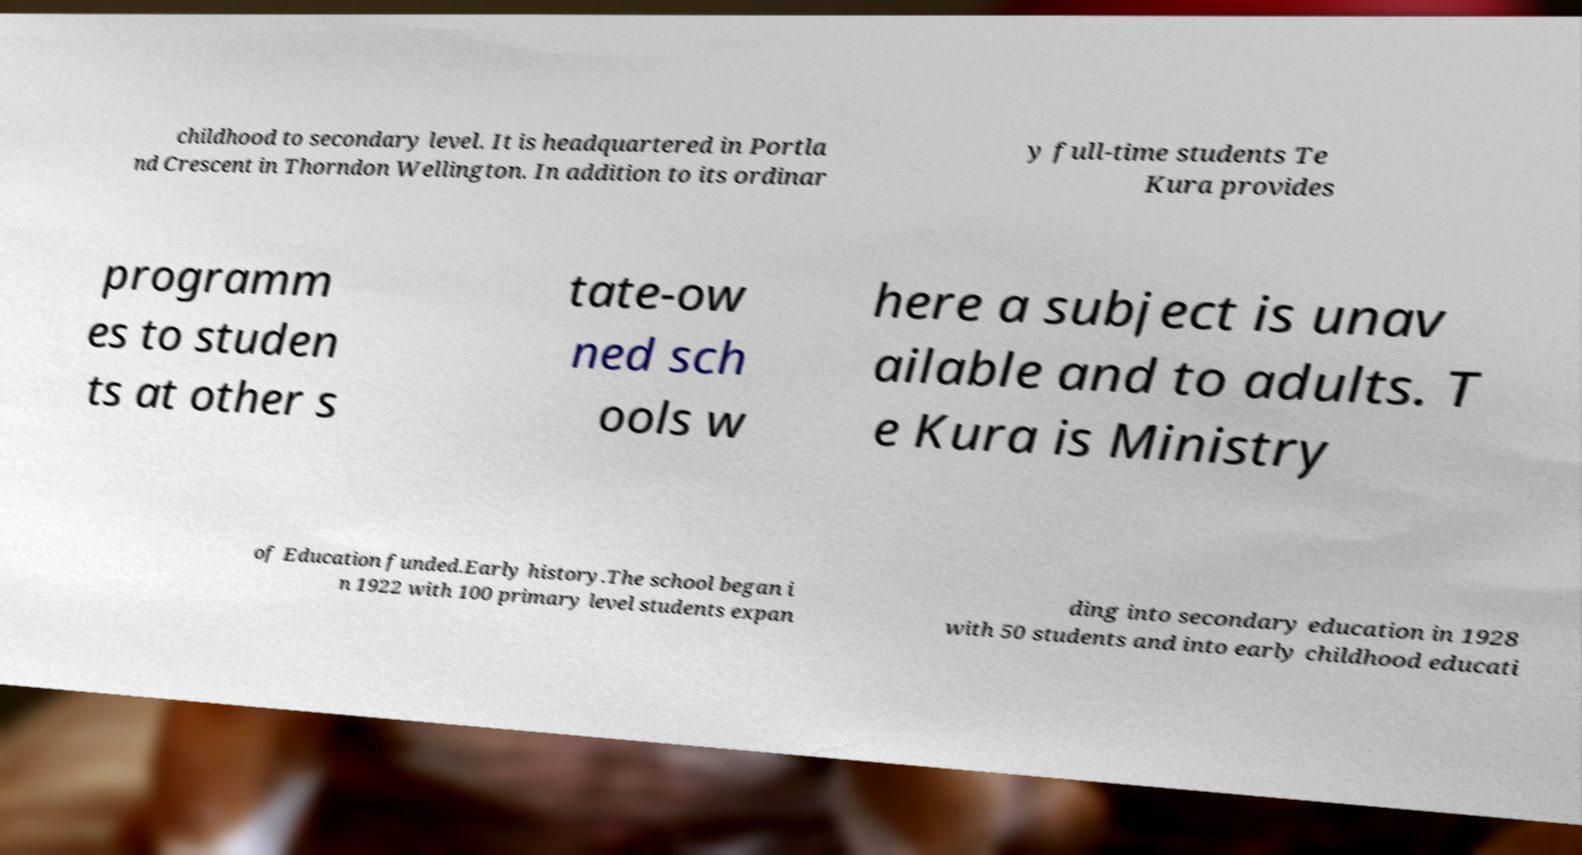Please identify and transcribe the text found in this image. childhood to secondary level. It is headquartered in Portla nd Crescent in Thorndon Wellington. In addition to its ordinar y full-time students Te Kura provides programm es to studen ts at other s tate-ow ned sch ools w here a subject is unav ailable and to adults. T e Kura is Ministry of Education funded.Early history.The school began i n 1922 with 100 primary level students expan ding into secondary education in 1928 with 50 students and into early childhood educati 